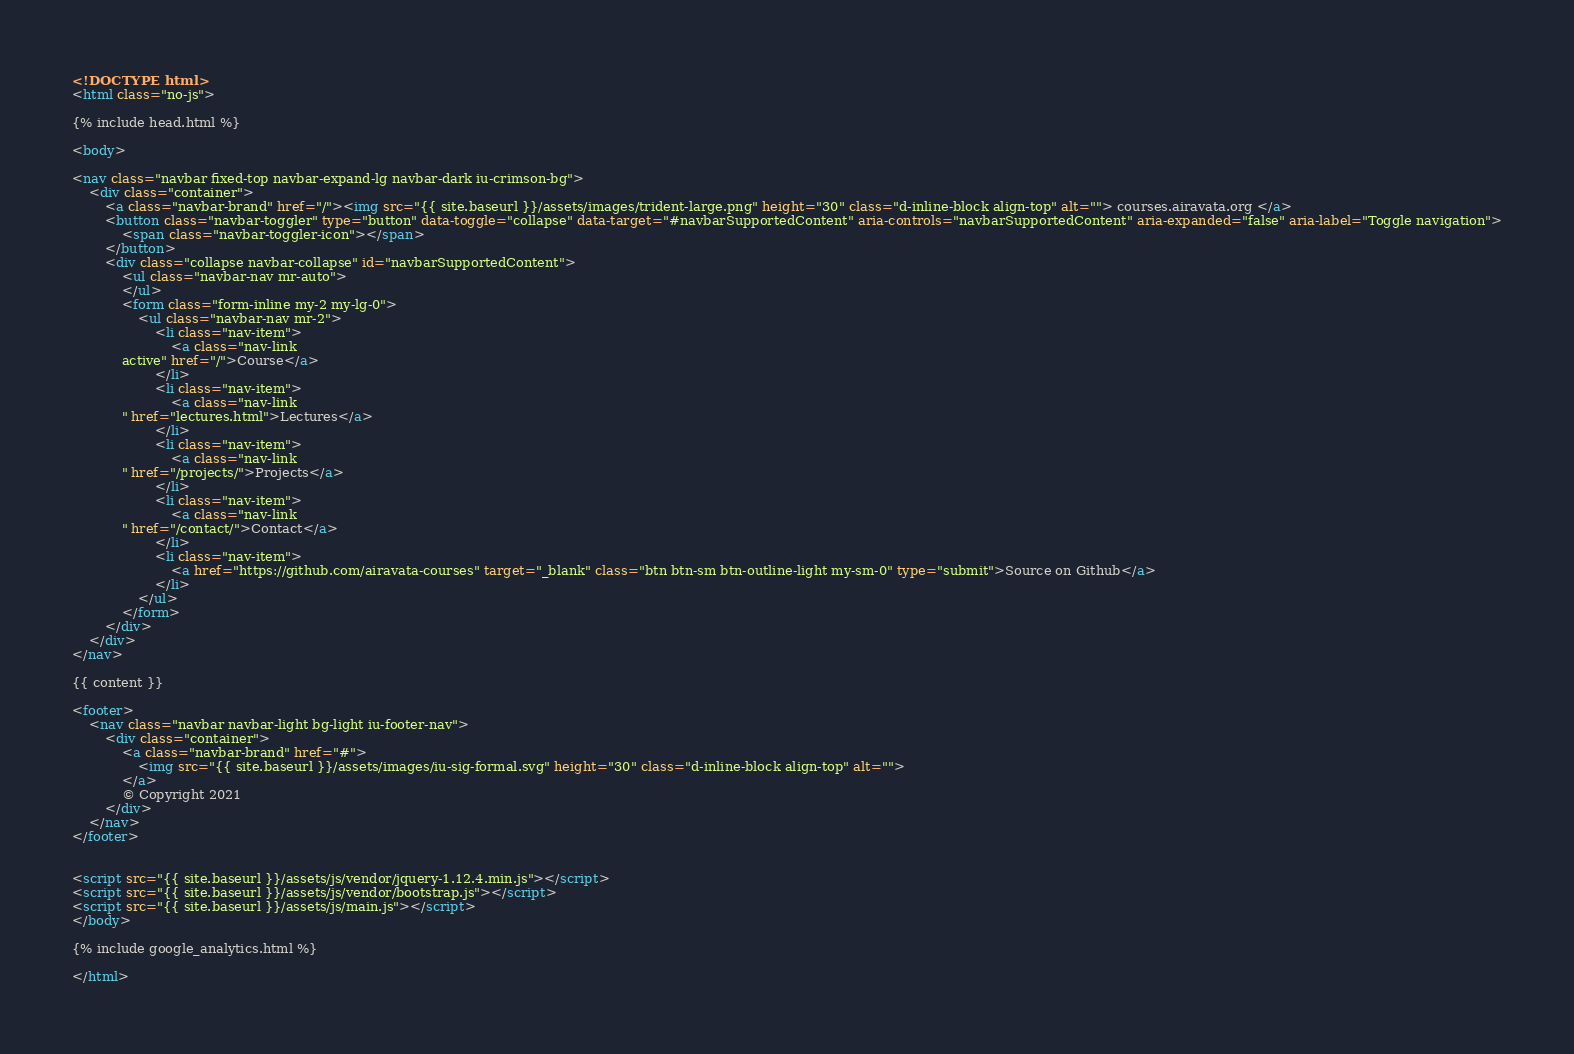<code> <loc_0><loc_0><loc_500><loc_500><_HTML_><!DOCTYPE html>
<html class="no-js">

{% include head.html %}

<body>

<nav class="navbar fixed-top navbar-expand-lg navbar-dark iu-crimson-bg">
    <div class="container">
        <a class="navbar-brand" href="/"><img src="{{ site.baseurl }}/assets/images/trident-large.png" height="30" class="d-inline-block align-top" alt=""> courses.airavata.org </a>
        <button class="navbar-toggler" type="button" data-toggle="collapse" data-target="#navbarSupportedContent" aria-controls="navbarSupportedContent" aria-expanded="false" aria-label="Toggle navigation">
            <span class="navbar-toggler-icon"></span>
        </button>
        <div class="collapse navbar-collapse" id="navbarSupportedContent">
            <ul class="navbar-nav mr-auto">
            </ul>
            <form class="form-inline my-2 my-lg-0">
                <ul class="navbar-nav mr-2">
                    <li class="nav-item">
                        <a class="nav-link
            active" href="/">Course</a>
                    </li>
                    <li class="nav-item">
                        <a class="nav-link
            " href="lectures.html">Lectures</a>
                    </li>
                    <li class="nav-item">
                        <a class="nav-link
            " href="/projects/">Projects</a>
                    </li>
                    <li class="nav-item">
                        <a class="nav-link
            " href="/contact/">Contact</a>
                    </li>
                    <li class="nav-item">
                        <a href="https://github.com/airavata-courses" target="_blank" class="btn btn-sm btn-outline-light my-sm-0" type="submit">Source on Github</a>
                    </li>
                </ul>
            </form>
        </div>
    </div>
</nav>

{{ content }}

<footer>
    <nav class="navbar navbar-light bg-light iu-footer-nav">
        <div class="container">
            <a class="navbar-brand" href="#">
                <img src="{{ site.baseurl }}/assets/images/iu-sig-formal.svg" height="30" class="d-inline-block align-top" alt="">
            </a>
            © Copyright 2021
        </div>
    </nav>
</footer>


<script src="{{ site.baseurl }}/assets/js/vendor/jquery-1.12.4.min.js"></script>
<script src="{{ site.baseurl }}/assets/js/vendor/bootstrap.js"></script>
<script src="{{ site.baseurl }}/assets/js/main.js"></script>
</body>

{% include google_analytics.html %}

</html></code> 